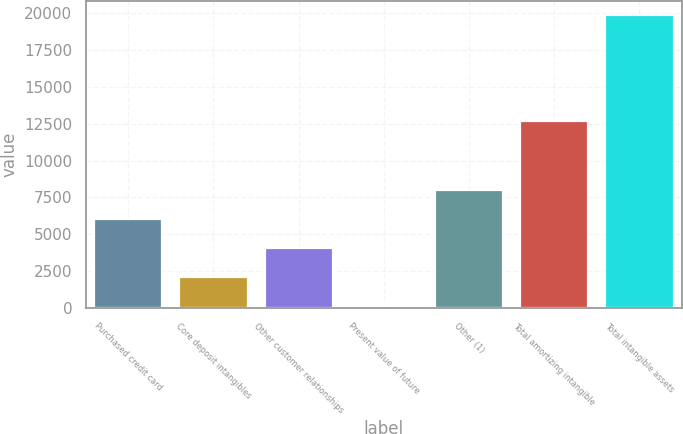<chart> <loc_0><loc_0><loc_500><loc_500><bar_chart><fcel>Purchased credit card<fcel>Core deposit intangibles<fcel>Other customer relationships<fcel>Present value of future<fcel>Other (1)<fcel>Total amortizing intangible<fcel>Total intangible assets<nl><fcel>6050.5<fcel>2117.5<fcel>4084<fcel>151<fcel>8017<fcel>12685<fcel>19816<nl></chart> 